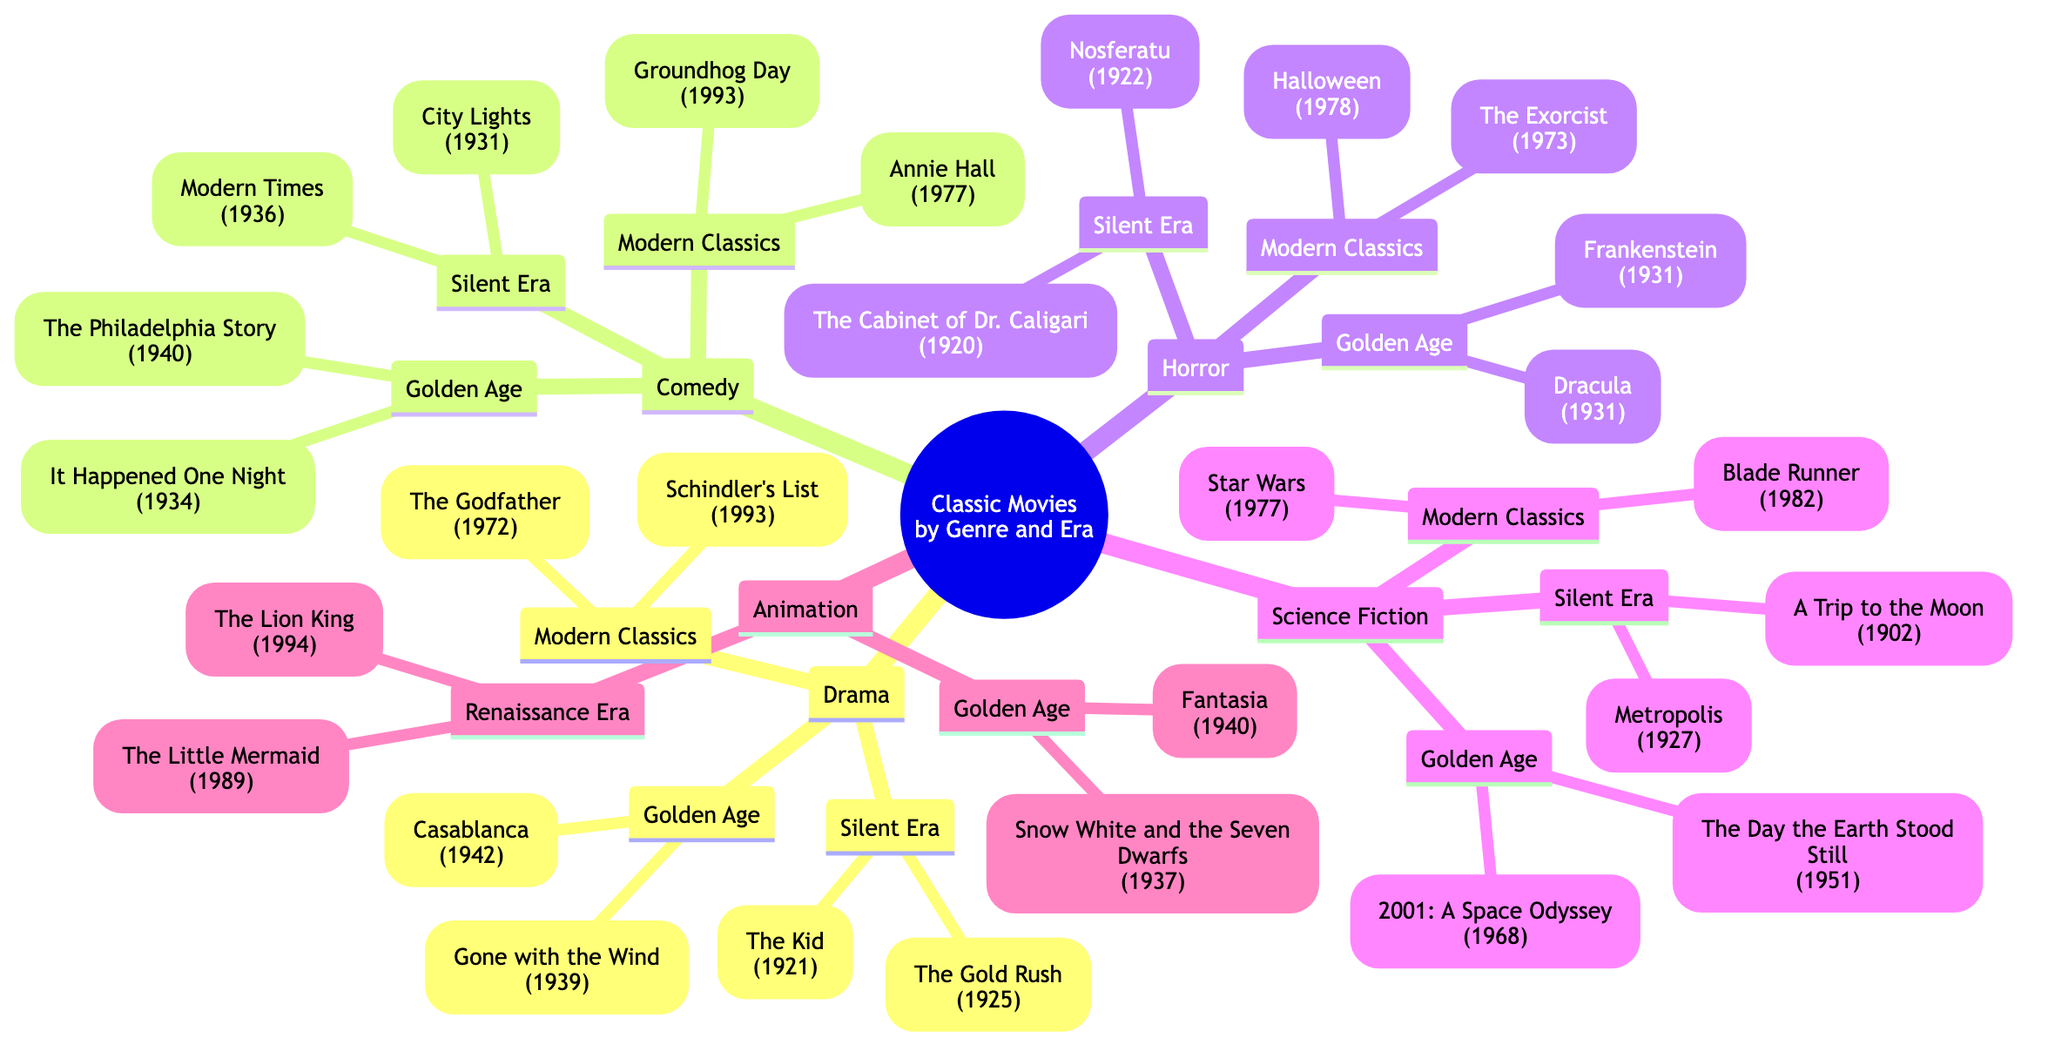What are two classic drama movies from the Silent Era? By examining the 'Drama' genre and navigating to the 'Silent Era' section, you can see the two movies listed are "The Kid (1921)" and "The Gold Rush (1925)."
Answer: The Kid (1921), The Gold Rush (1925) How many genres are listed in the diagram? The diagram presents five main genres: Drama, Comedy, Horror, Science Fiction, and Animation. Counting these genres gives a total of five.
Answer: 5 Which comedy movie from the Modern Classics era was released in 1993? Looking at the 'Comedy' genre and then checking the 'Modern Classics' section, "Groundhog Day (1993)" is the movie released in that year.
Answer: Groundhog Day (1993) What is the common type of horror movies listed in the Golden Age era? In the 'Horror' section under the 'Golden Age,' you will find two movies: "Frankenstein (1931)" and "Dracula (1931)," which are both types of horror films.
Answer: Frankenstein, Dracula Which science fiction movie released in 1951 is featured in the diagram? In the 'Science Fiction' genre, under the 'Golden Age' section, "The Day the Earth Stood Still (1951)" is the film listed for that year.
Answer: The Day the Earth Stood Still (1951) What are the two classic animation films from the Renaissance Era? Checking the 'Animation' genre and going to the 'Renaissance Era,' the films identified are "The Little Mermaid (1989)" and "The Lion King (1994)."
Answer: The Little Mermaid (1989), The Lion King (1994) Which genre includes the movie "The Godfather"? By navigating to the 'Modern Classics' section in the 'Drama' genre, it is clear that "The Godfather (1972)" belongs to this category.
Answer: Drama How many classic horror films were released during the Silent Era? In the 'Horror' genre under the 'Silent Era,' there are two films listed: "Nosferatu (1922)" and "The Cabinet of Dr. Caligari (1920)," so the total is two movies.
Answer: 2 What era features the earliest science fiction film listed in the diagram? Within the 'Science Fiction' genre, the 'Silent Era' showcases "A Trip to the Moon (1902)" and "Metropolis (1927)," making it the earliest era represented.
Answer: Silent Era 